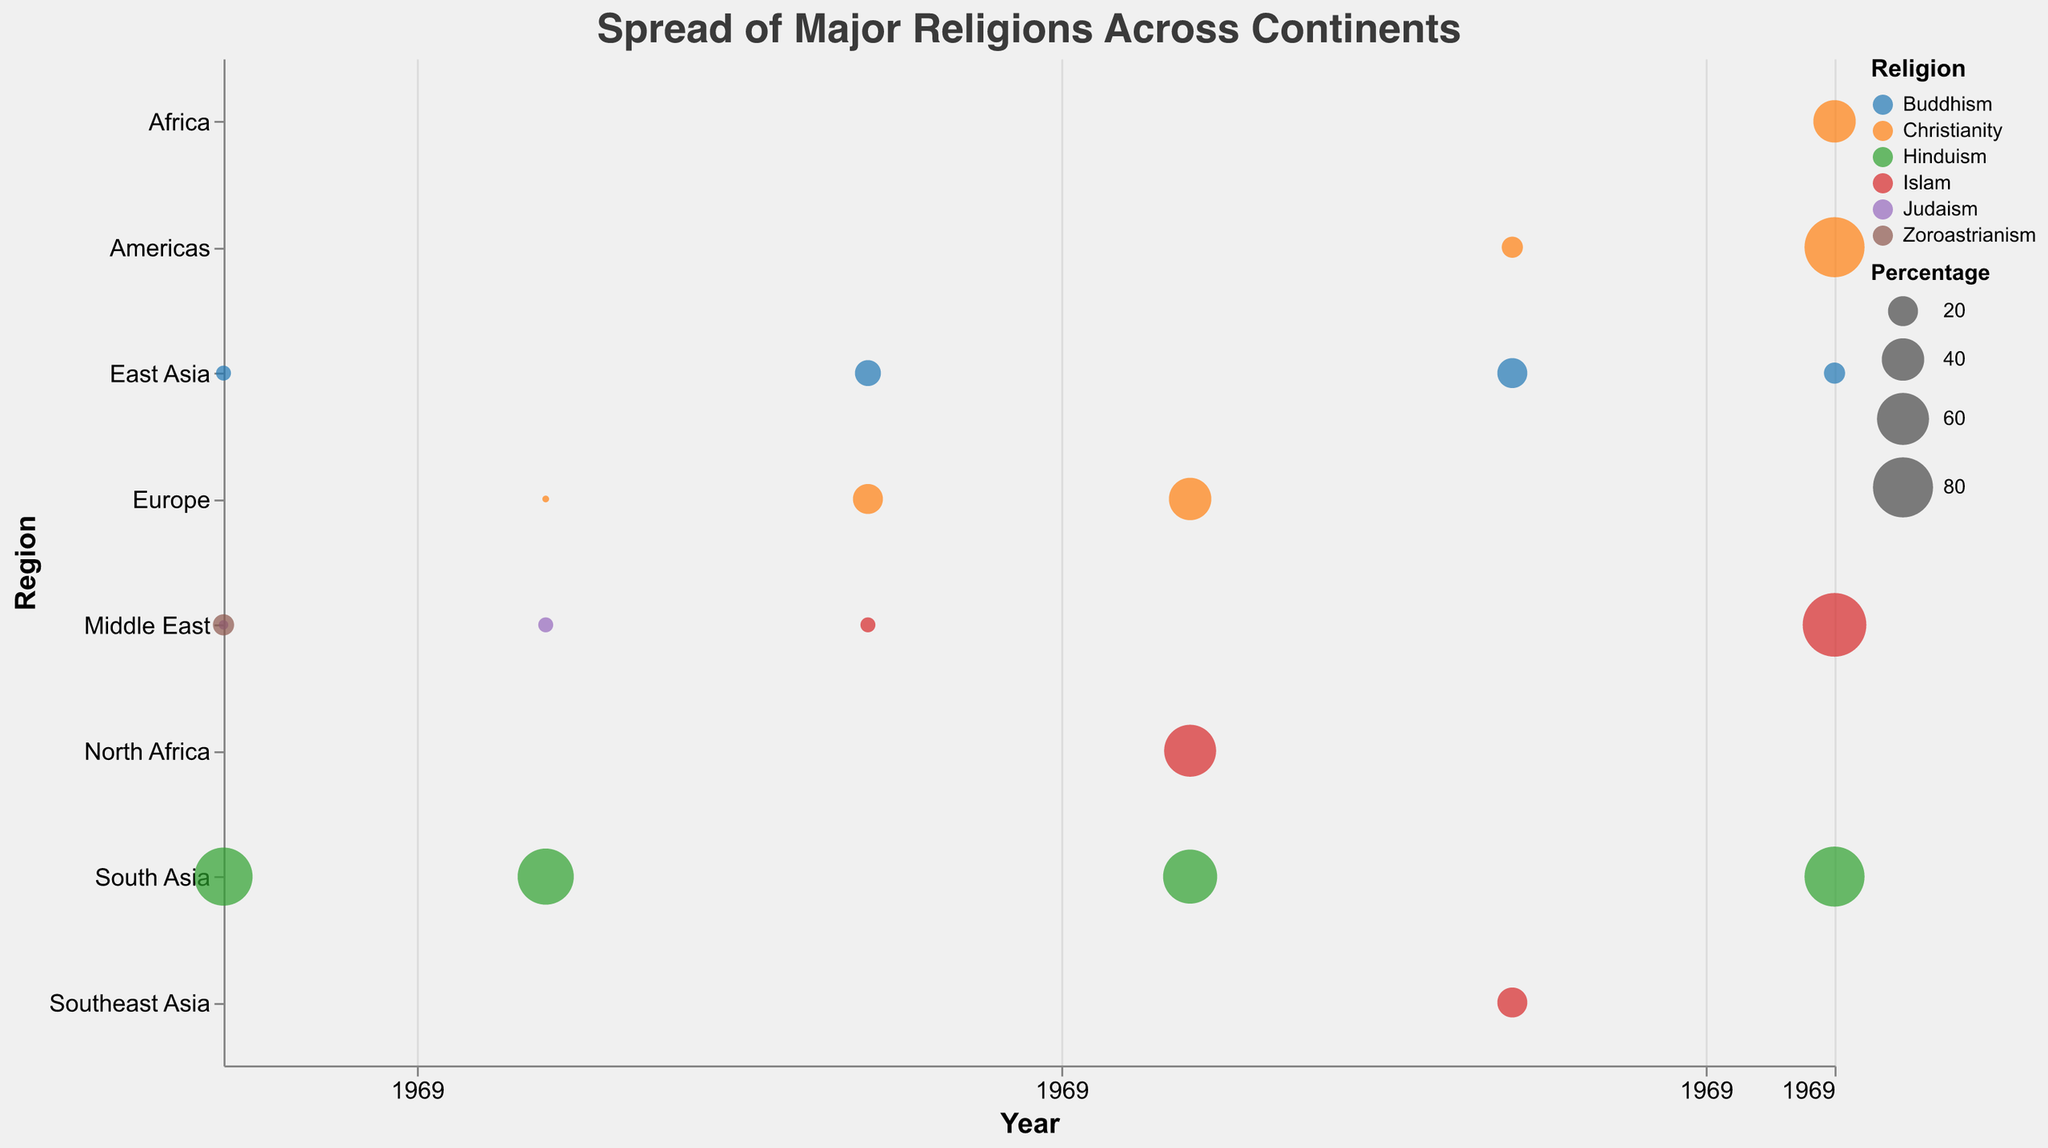what is the title of the figure? The title of the figure is prominently displayed near the top and often uses a larger font size compared to other text elements in the figure.
Answer: Spread of Major Religions Across Continents Which religion was most prominent in South Asia around 500 BCE? Look for the circle in South Asia for the year 500 BCE and check the color and legend for the highest percentage. Hinduism has the largest circle.
Answer: Hinduism At what year did Islam become the dominant religion in North Africa? Identify the circles in North Africa, and note the year and religion with the largest percentage. Islam became dominant in North Africa around 1000 CE.
Answer: 1000 CE Which region had the highest percentage of Christianity in the year 2000? Look at the year 2000 and identify the regions with Christianity, then compare their sizes. The Americas had the largest circle, indicating the highest percentage.
Answer: Americas What happened to the percentage of Buddhism in East Asia from 500 BCE to the year 2000? Compare the size of the circles for Buddhism in East Asia across the years 500 BCE and 2000. Note how the size (percentage) changes between these years from 5% in 500 BCE to 10% in the year 2000.
Answer: It doubled In 1500, which region had a higher percentage of Islam: Middle East or Southeast Asia? Compare the sizes of the circles for Islam in the Middle East and Southeast Asia around the year 1500. Southeast Asia has a larger circle than the Middle East for Islam in that year.
Answer: Southeast Asia How did the percentage of Christianity in Europe change from year 0 to 1500? Look at both the year 0 and the year 1500 for Europe, compare the sizes of the circles representing Christianity, which increased from 1% to 40%.
Answer: It increased Which religion had a notable presence in the Middle East around 500 BCE but not in 2000? Check the data points in the Middle East for both 500 BCE and 2000 to identify any religion present in the former but not in the latter. Zoroastrianism was present in 500 BCE but not in 2000.
Answer: Zoroastrianism What trend can be observed about the spread of Christianity in the Americas between 1500 and 2000? Compare the size of the circles for Christianity in the Americas in 1500 and 2000, noting the substantial increase in the percentage from 10% to 80%.
Answer: Significant increase 